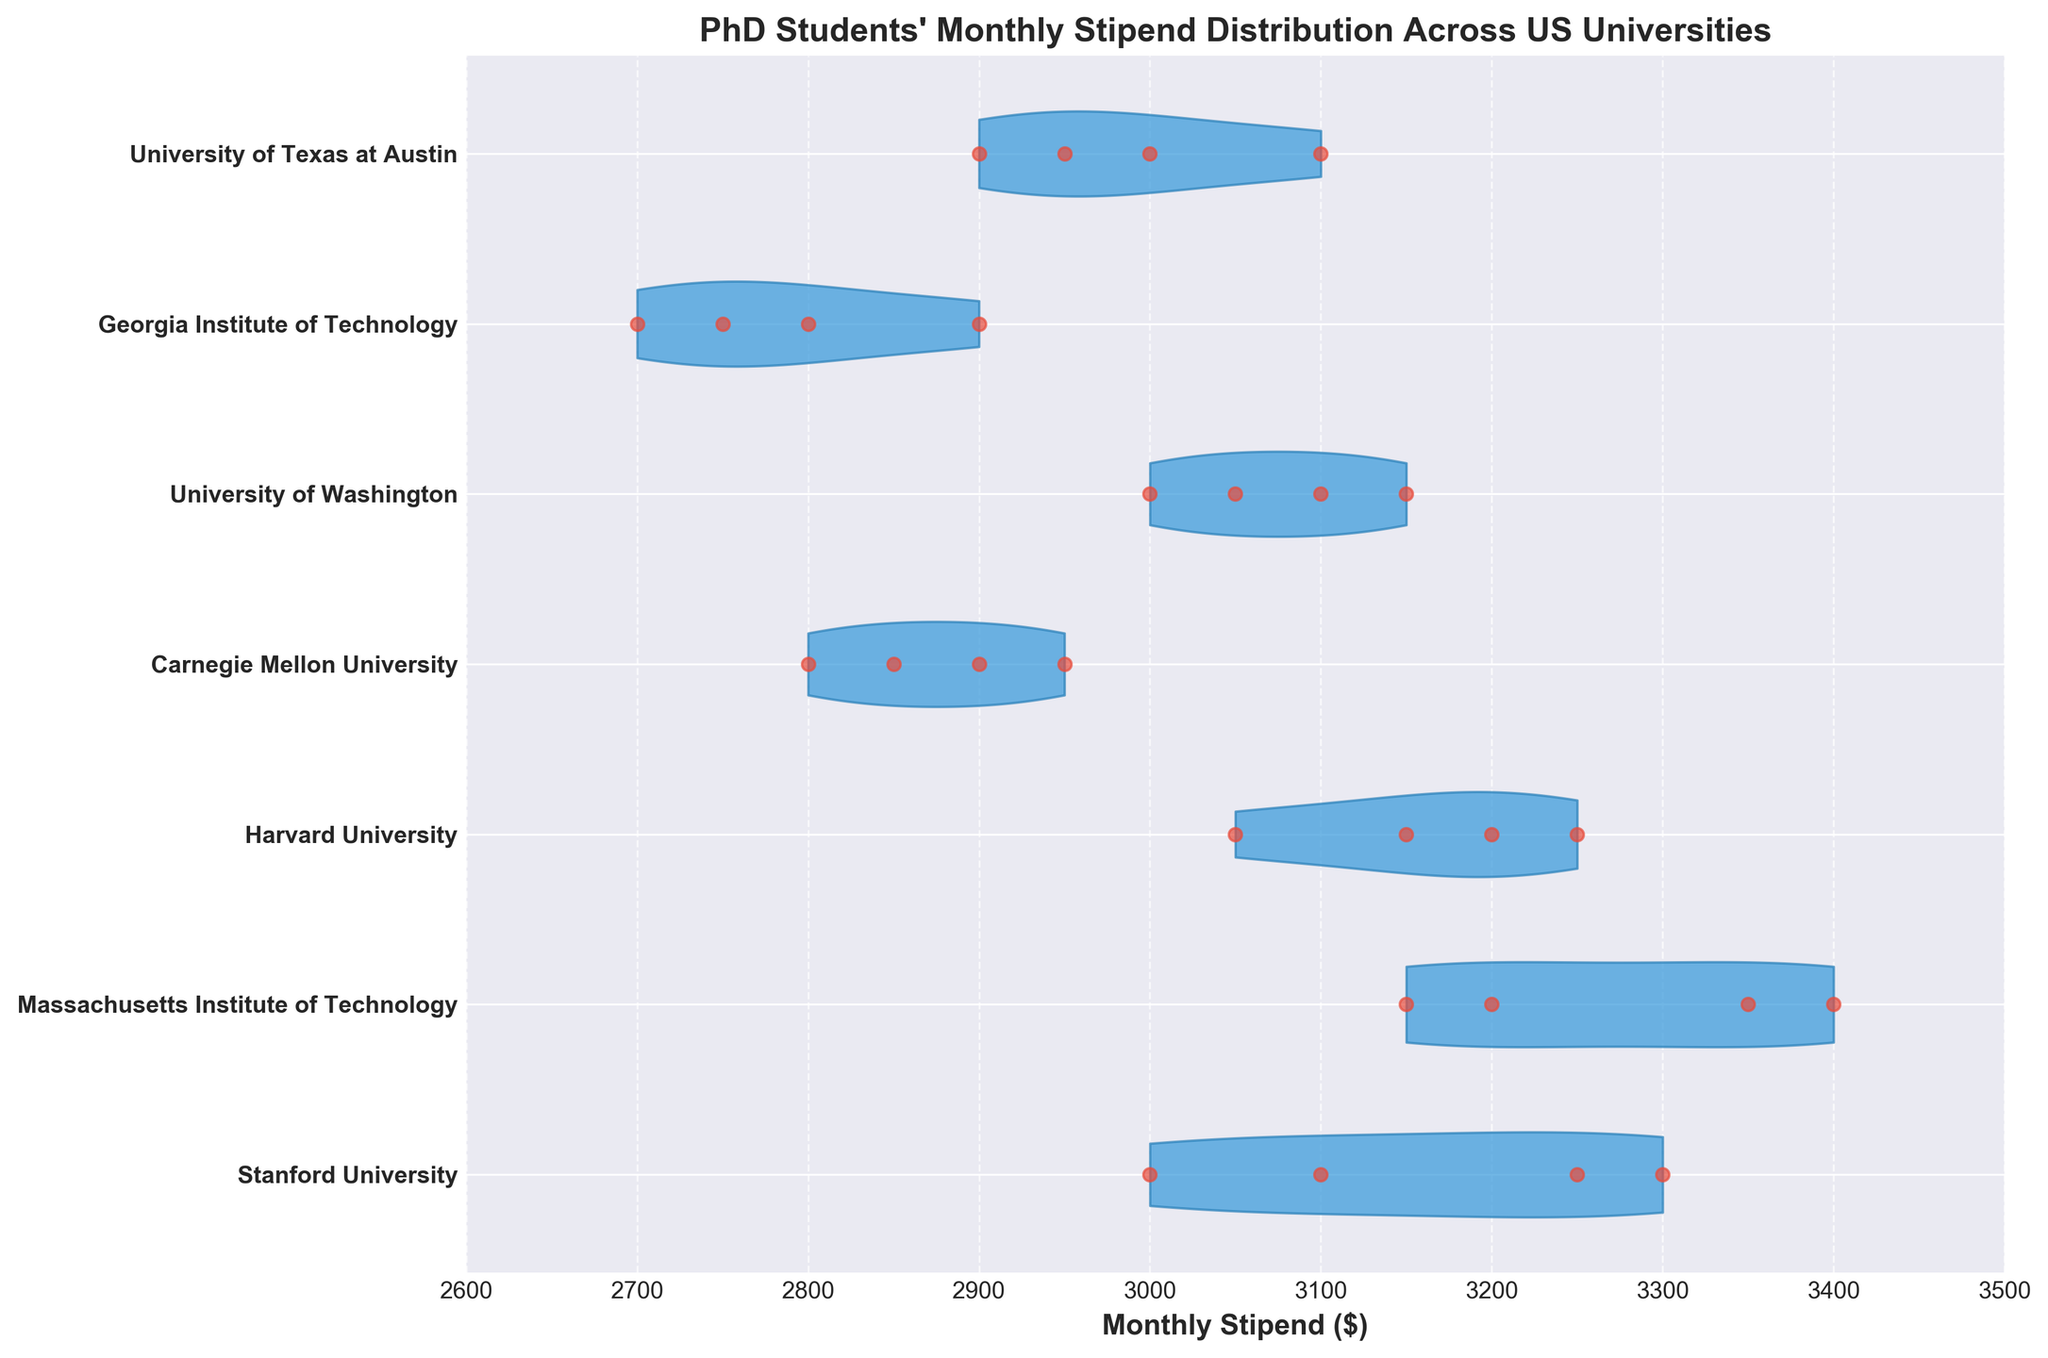Which university has the highest variability in monthly stipend? By examining the spread and shape of each violin, we can determine that Massachusetts Institute of Technology has the widest spread, indicating the highest variability.
Answer: Massachusetts Institute of Technology What is the range of monthly stipends for Stanford University? The specific points at the edges of the Stanford University violin show the minimum and maximum values. The minimum is $3000 and the maximum is $3300, so the range is $3300 - $3000 = $300.
Answer: $300 Which universities have the same maximum monthly stipend? By comparing the rightmost tips of the violins, we can see that Stanford University and Massachusetts Institute of Technology both have maximum stipends at $3400.
Answer: Stanford University, Massachusetts Institute of Technology Which university has the smallest median monthly stipend? The university with the narrowest central part of the violin close to the lowest data point signifies the smallest median value. Georgia Institute of Technology appears to have the smallest median stipend, centered around $2800.
Answer: Georgia Institute of Technology Are there any universities with overlapping stipend ranges? If so, which ones? By observing the width of the violins and the spread of points, we can see overlap between Carnegie Mellon University and University of Texas at Austin, as well as Georgia Institute of Technology and Carnegie Mellon University at their stipend ranges.
Answer: Carnegie Mellon University & University of Texas at Austin, Georgia Institute of Technology & Carnegie Mellon University What is the stipend distribution for University of Washington? By looking at the shape of the University of Washington's violin, we can see that the stipends range from $3000 to $3150, with more density around $3050.
Answer: $3000-$3150, dense around $3050 Which university has the highest density of the highest stipends? The density is shown by the width of the violin near the top stipend values. Massachusetts Institute of Technology has a thicker distribution near the highest range, around $3400.
Answer: Massachusetts Institute of Technology Do Stanford University and Harvard University have similar stipend distributions? Comparing the shapes and densities of the violins, both universities show a similar central tendency and maximum values around $3250-$3300, but Stanford has a wider spread.
Answer: Yes, with some differences Which university has the lowest minimum stipend? The leftmost edge of the violins can indicate the minimum stipends, showing that Georgia Institute of Technology's minimum is $2700.
Answer: Georgia Institute of Technology Is there a general trend in stipend amounts among these universities? By observing the horizontal location of most distributions, stipends generally range from $2700 to $3400, with the highest densities around $3000-$3200.
Answer: $2700-$3400, high density around $3000-$3200 